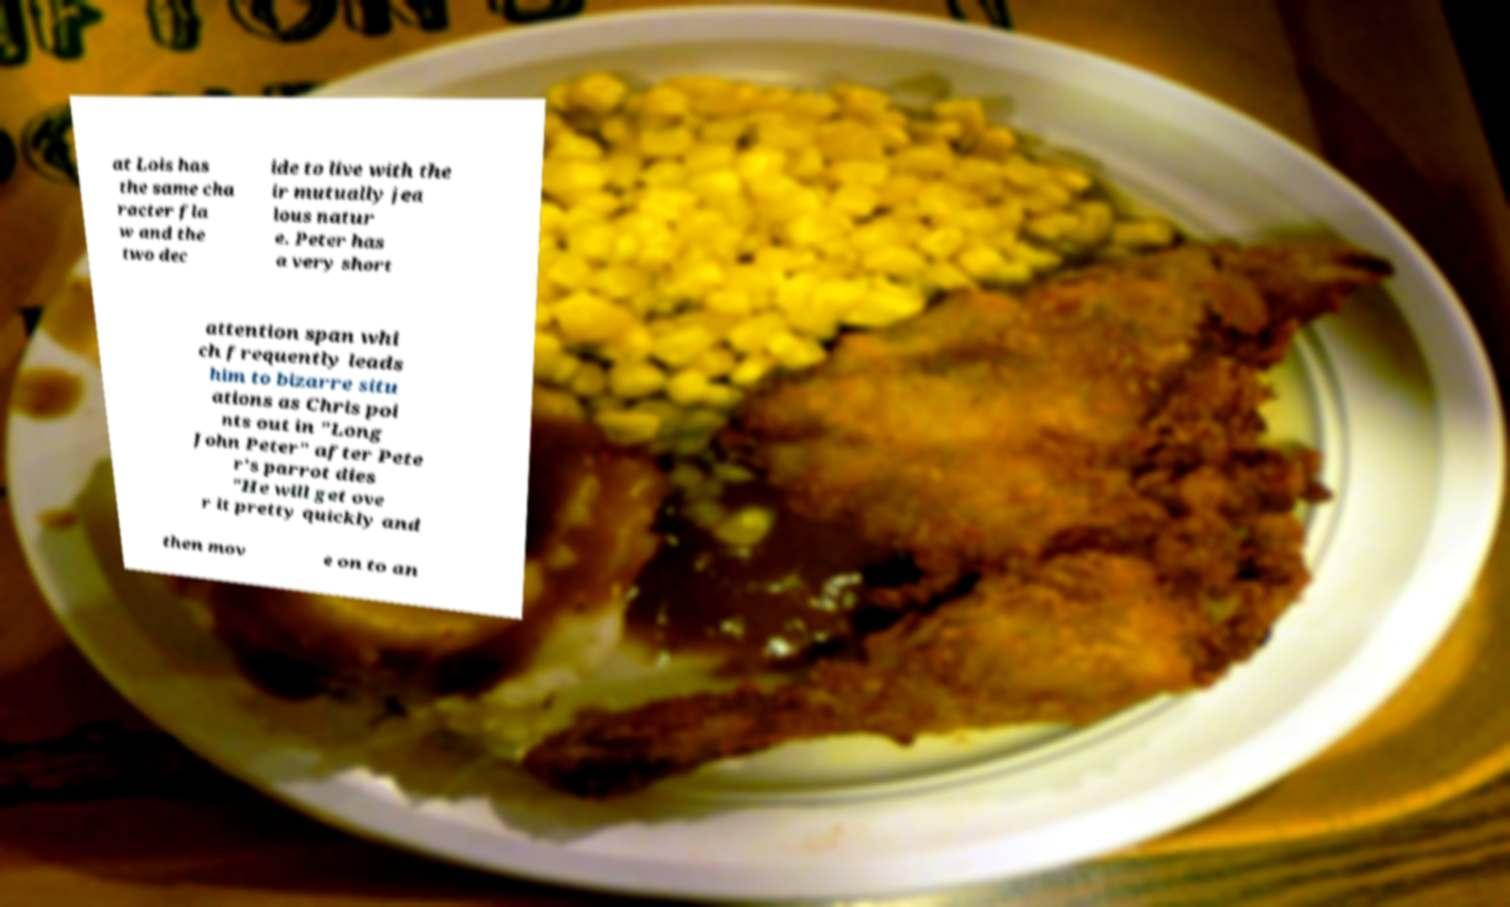Please identify and transcribe the text found in this image. at Lois has the same cha racter fla w and the two dec ide to live with the ir mutually jea lous natur e. Peter has a very short attention span whi ch frequently leads him to bizarre situ ations as Chris poi nts out in "Long John Peter" after Pete r's parrot dies "He will get ove r it pretty quickly and then mov e on to an 